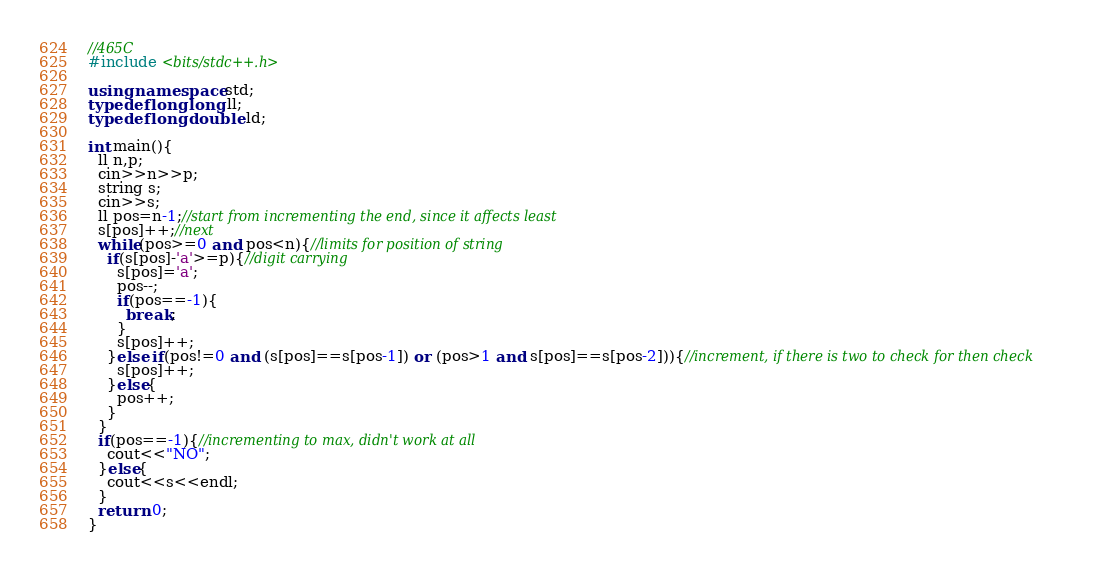Convert code to text. <code><loc_0><loc_0><loc_500><loc_500><_C++_>//465C
#include <bits/stdc++.h>

using namespace std;
typedef long long ll;
typedef long double ld;

int main(){
  ll n,p;
  cin>>n>>p;
  string s;
  cin>>s;
  ll pos=n-1;//start from incrementing the end, since it affects least
  s[pos]++;//next
  while(pos>=0 and pos<n){//limits for position of string
    if(s[pos]-'a'>=p){//digit carrying
      s[pos]='a';
      pos--;
      if(pos==-1){
        break;
      }
      s[pos]++;
    }else if(pos!=0 and (s[pos]==s[pos-1]) or (pos>1 and s[pos]==s[pos-2])){//increment, if there is two to check for then check
      s[pos]++;
    }else{
      pos++;
    }
  }
  if(pos==-1){//incrementing to max, didn't work at all
    cout<<"NO";
  }else{
    cout<<s<<endl;
  }
  return 0;
}
</code> 